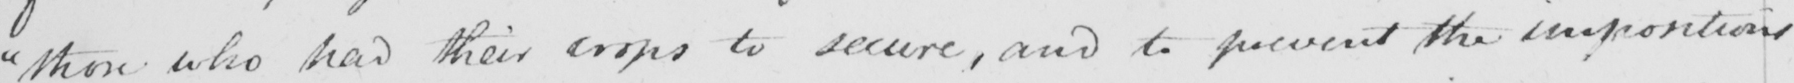Transcribe the text shown in this historical manuscript line. " those who had their crops to secure , and to prevent the impositions 